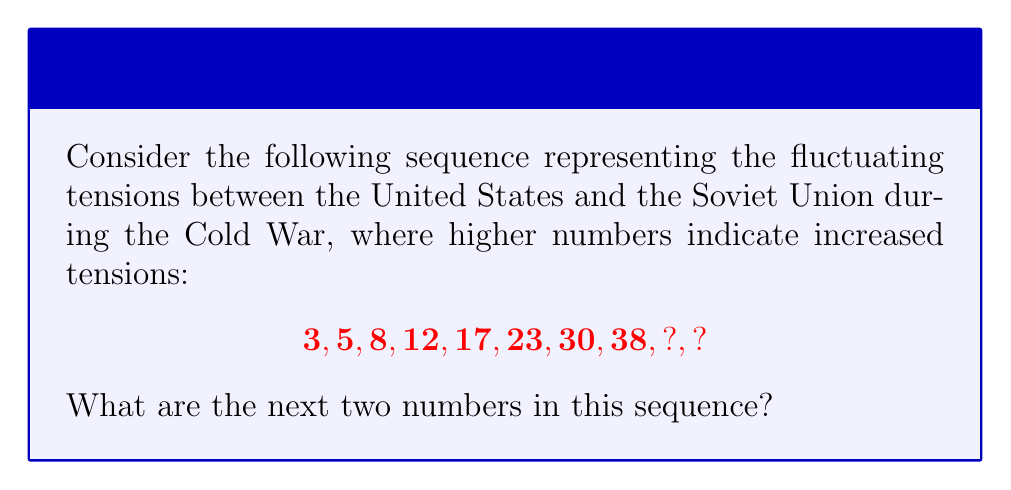Give your solution to this math problem. To solve this problem, we need to analyze the pattern in the given sequence:

1) First, let's calculate the differences between consecutive terms:
   $5 - 3 = 2$
   $8 - 5 = 3$
   $12 - 8 = 4$
   $17 - 12 = 5$
   $23 - 17 = 6$
   $30 - 23 = 7$
   $38 - 30 = 8$

2) We can observe that the differences form an arithmetic sequence: 2, 3, 4, 5, 6, 7, 8

3) This suggests that the next difference will be 9, and the one after that will be 10

4) To find the next number in the original sequence:
   $38 + 9 = 47$

5) For the number after that:
   $47 + 10 = 57$

Therefore, the next two numbers in the sequence are 47 and 57.
Answer: 47, 57 